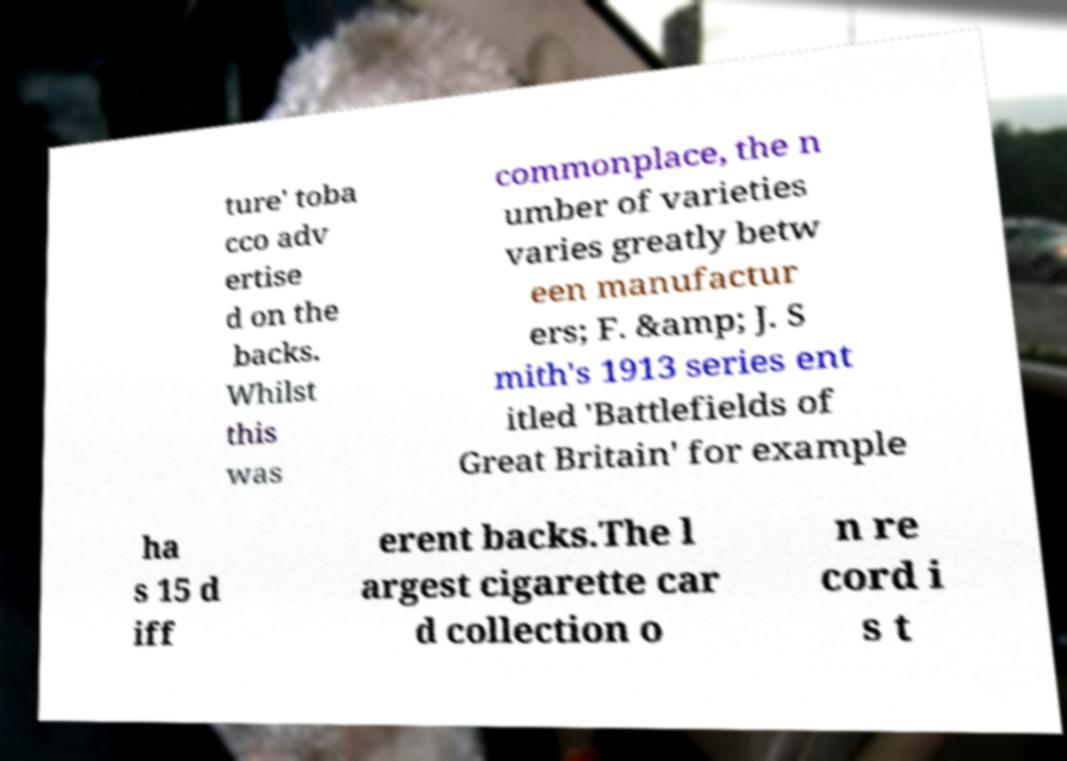Can you accurately transcribe the text from the provided image for me? ture' toba cco adv ertise d on the backs. Whilst this was commonplace, the n umber of varieties varies greatly betw een manufactur ers; F. &amp; J. S mith's 1913 series ent itled 'Battlefields of Great Britain' for example ha s 15 d iff erent backs.The l argest cigarette car d collection o n re cord i s t 